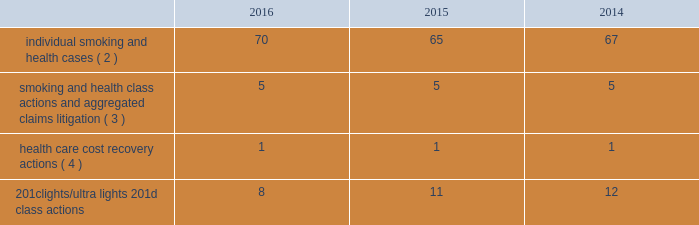Altria group , inc .
And subsidiaries notes to consolidated financial statements _________________________ may not be obtainable in all cases .
This risk has been substantially reduced given that 47 states and puerto rico limit the dollar amount of bonds or require no bond at all .
As discussed below , however , tobacco litigation plaintiffs have challenged the constitutionality of florida 2019s bond cap statute in several cases and plaintiffs may challenge state bond cap statutes in other jurisdictions as well .
Such challenges may include the applicability of state bond caps in federal court .
States , including florida , may also seek to repeal or alter bond cap statutes through legislation .
Although altria group , inc .
Cannot predict the outcome of such challenges , it is possible that the consolidated results of operations , cash flows or financial position of altria group , inc. , or one or more of its subsidiaries , could be materially affected in a particular fiscal quarter or fiscal year by an unfavorable outcome of one or more such challenges .
Altria group , inc .
And its subsidiaries record provisions in the consolidated financial statements for pending litigation when they determine that an unfavorable outcome is probable and the amount of the loss can be reasonably estimated .
At the present time , while it is reasonably possible that an unfavorable outcome in a case may occur , except to the extent discussed elsewhere in this note 19 .
Contingencies : ( i ) management has concluded that it is not probable that a loss has been incurred in any of the pending tobacco-related cases ; ( ii ) management is unable to estimate the possible loss or range of loss that could result from an unfavorable outcome in any of the pending tobacco-related cases ; and ( iii ) accordingly , management has not provided any amounts in the consolidated financial statements for unfavorable outcomes , if any .
Litigation defense costs are expensed as incurred .
Altria group , inc .
And its subsidiaries have achieved substantial success in managing litigation .
Nevertheless , litigation is subject to uncertainty and significant challenges remain .
It is possible that the consolidated results of operations , cash flows or financial position of altria group , inc. , or one or more of its subsidiaries , could be materially affected in a particular fiscal quarter or fiscal year by an unfavorable outcome or settlement of certain pending litigation .
Altria group , inc .
And each of its subsidiaries named as a defendant believe , and each has been so advised by counsel handling the respective cases , that it has valid defenses to the litigation pending against it , as well as valid bases for appeal of adverse verdicts .
Each of the companies has defended , and will continue to defend , vigorously against litigation challenges .
However , altria group , inc .
And its subsidiaries may enter into settlement discussions in particular cases if they believe it is in the best interests of altria group , inc .
To do so .
Overview of altria group , inc .
And/or pm usa tobacco- related litigation types and number of cases : claims related to tobacco products generally fall within the following categories : ( i ) smoking and health cases alleging personal injury brought on behalf of individual plaintiffs ; ( ii ) smoking and health cases primarily alleging personal injury or seeking court-supervised programs for ongoing medical monitoring and purporting to be brought on behalf of a class of individual plaintiffs , including cases in which the aggregated claims of a number of individual plaintiffs are to be tried in a single proceeding ; ( iii ) health care cost recovery cases brought by governmental ( both domestic and foreign ) plaintiffs seeking reimbursement for health care expenditures allegedly caused by cigarette smoking and/or disgorgement of profits ; ( iv ) class action suits alleging that the uses of the terms 201clights 201d and 201cultra lights 201d constitute deceptive and unfair trade practices , common law or statutory fraud , unjust enrichment , breach of warranty or violations of the racketeer influenced and corrupt organizations act ( 201crico 201d ) ; and ( v ) other tobacco-related litigation described below .
Plaintiffs 2019 theories of recovery and the defenses raised in pending smoking and health , health care cost recovery and 201clights/ultra lights 201d cases are discussed below .
The table below lists the number of certain tobacco-related cases pending in the united states against pm usa ( 1 ) and , in some instances , altria group , inc .
As of december 31 , 2016 , 2015 and 2014: .
( 1 ) does not include 25 cases filed on the asbestos docket in the circuit court for baltimore city , maryland , which seek to join pm usa and other cigarette- manufacturing defendants in complaints previously filed against asbestos companies .
( 2 ) does not include 2485 cases brought by flight attendants seeking compensatory damages for personal injuries allegedly caused by exposure to environmental tobacco smoke ( 201cets 201d ) .
The flight attendants allege that they are members of an ets smoking and health class action in florida , which was settled in 1997 ( broin ) .
The terms of the court-approved settlement in that case allowed class members to file individual lawsuits seeking compensatory damages , but prohibited them from seeking punitive damages .
Also , does not include individual smoking and health cases brought by or on behalf of plaintiffs in florida state and federal courts following the decertification of the engle case ( discussed below in smoking and health litigation - engle class action ) .
( 3 ) includes as one case the 600 civil actions ( of which 344 were actions against pm usa ) that were to be tried in a single proceeding in west virginia ( in re : tobacco litigation ) .
The west virginia supreme court of appeals ruled that the united states constitution did not preclude a trial in two phases in this case .
Issues related to defendants 2019 conduct and whether punitive damages are permissible were tried in the first phase .
Trial in the first phase of this case began in april 2013 .
In may 2013 , the jury returned a verdict in favor of defendants on the claims for design defect , negligence , failure to warn , breach of warranty , and concealment and declined to find that the defendants 2019 conduct warranted punitive damages .
Plaintiffs prevailed on their claim that ventilated filter cigarettes should have included use instructions for the period 1964 - 1969 .
The second phase will consist of trials to determine liability and compensatory damages .
In november 2014 , the west virginia supreme court of appeals affirmed the final judgment .
In july 2015 , the trial court entered an order that will result in the entry of final judgment in favor of defendants and against all but 30 plaintiffs who potentially have a claim against one or more defendants that may be pursued in a second phase of trial .
The court intends to try the claims of these 30 plaintiffs in six consolidated trials , each with a group of five plaintiffs .
The first trial is currently scheduled to begin may 1 , 2018 .
Dates for the five remaining consolidated trials have not been scheduled .
( 4 ) see health care cost recovery litigation - federal government 2019s lawsuit below. .
What are the total number of pending tobacco-related cases in united states in 2015? 
Computations: (((65 + 5) + 1) + 11)
Answer: 82.0. 